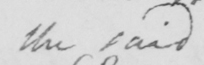What does this handwritten line say? the said 